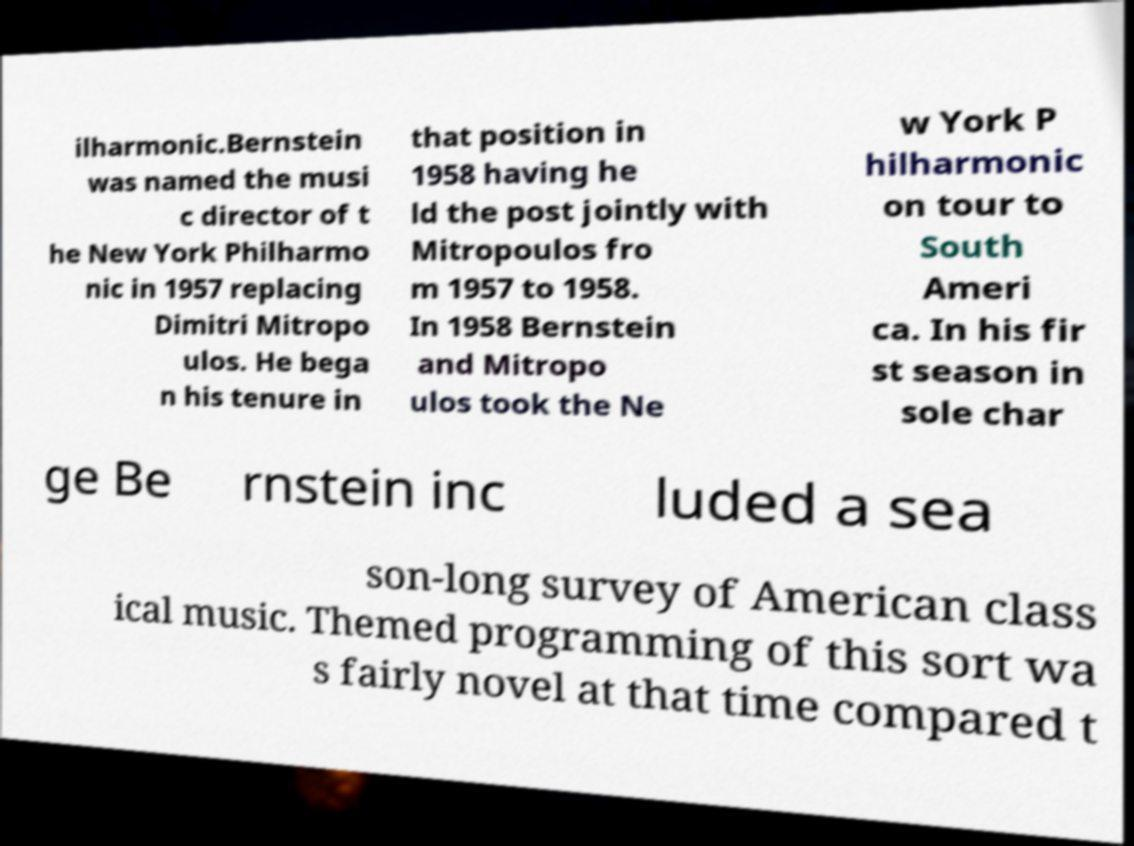Could you assist in decoding the text presented in this image and type it out clearly? ilharmonic.Bernstein was named the musi c director of t he New York Philharmo nic in 1957 replacing Dimitri Mitropo ulos. He bega n his tenure in that position in 1958 having he ld the post jointly with Mitropoulos fro m 1957 to 1958. In 1958 Bernstein and Mitropo ulos took the Ne w York P hilharmonic on tour to South Ameri ca. In his fir st season in sole char ge Be rnstein inc luded a sea son-long survey of American class ical music. Themed programming of this sort wa s fairly novel at that time compared t 